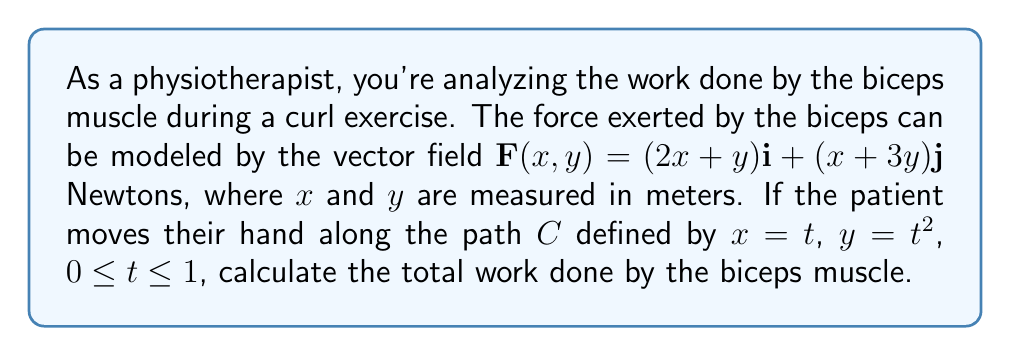Can you solve this math problem? To solve this problem, we need to use the line integral of a vector field, which represents the work done by a force along a path. The steps are as follows:

1) The work done is given by the line integral:
   $$W = \int_C \mathbf{F} \cdot d\mathbf{r}$$

2) We have $\mathbf{F}(x,y) = (2x+y)\mathbf{i} + (x+3y)\mathbf{j}$ and the path $C$ is defined by $x=t$, $y=t^2$, $0 \leq t \leq 1$.

3) We need to express $d\mathbf{r}$ in terms of $t$:
   $$d\mathbf{r} = \frac{dx}{dt}\mathbf{i} + \frac{dy}{dt}\mathbf{j} = 1\mathbf{i} + 2t\mathbf{j}$$

4) Now, we can set up the integral:
   $$W = \int_0^1 [(2t+t^2)(1) + (t+3t^2)(2t)] dt$$

5) Simplify the integrand:
   $$W = \int_0^1 (2t+t^2 + 2t^2+6t^3) dt$$
   $$W = \int_0^1 (2t+3t^2+6t^3) dt$$

6) Integrate:
   $$W = [t^2 + t^3 + \frac{3}{2}t^4]_0^1$$

7) Evaluate the integral:
   $$W = (1 + 1 + \frac{3}{2}) - (0 + 0 + 0) = \frac{7}{2}$$

Therefore, the total work done by the biceps muscle is $\frac{7}{2}$ Joules.
Answer: $\frac{7}{2}$ J 